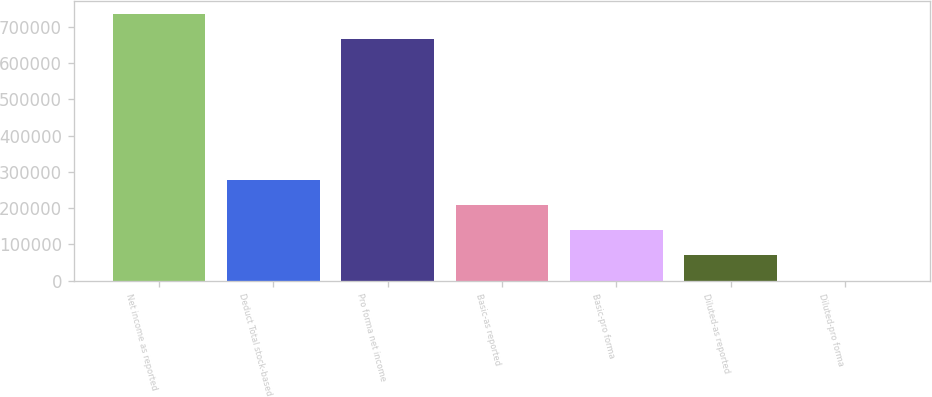<chart> <loc_0><loc_0><loc_500><loc_500><bar_chart><fcel>Net income as reported<fcel>Deduct Total stock-based<fcel>Pro forma net income<fcel>Basic-as reported<fcel>Basic-pro forma<fcel>Diluted-as reported<fcel>Diluted-pro forma<nl><fcel>735413<fcel>279076<fcel>665666<fcel>209328<fcel>139581<fcel>69833.9<fcel>86.67<nl></chart> 